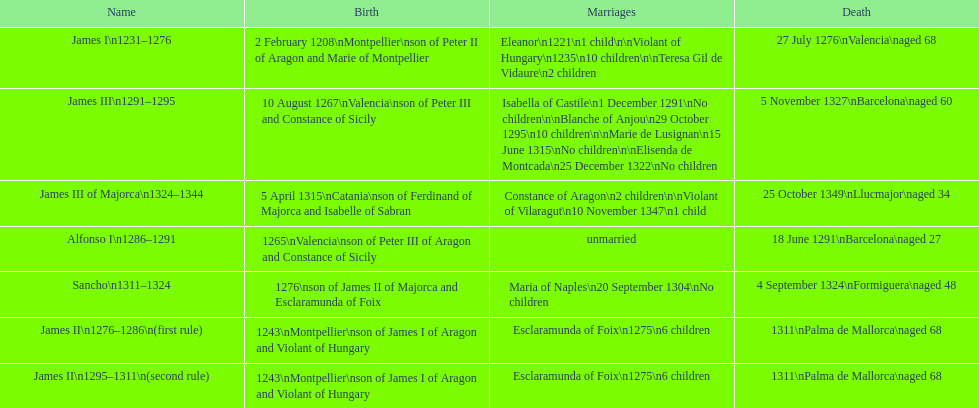Which two monarchs had no children? Alfonso I, Sancho. 